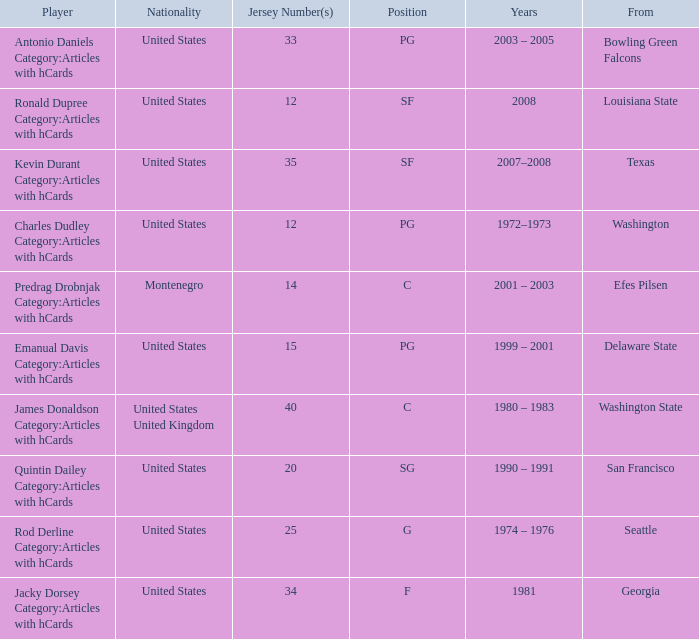What was the nationality of the players with a position of g? United States. 